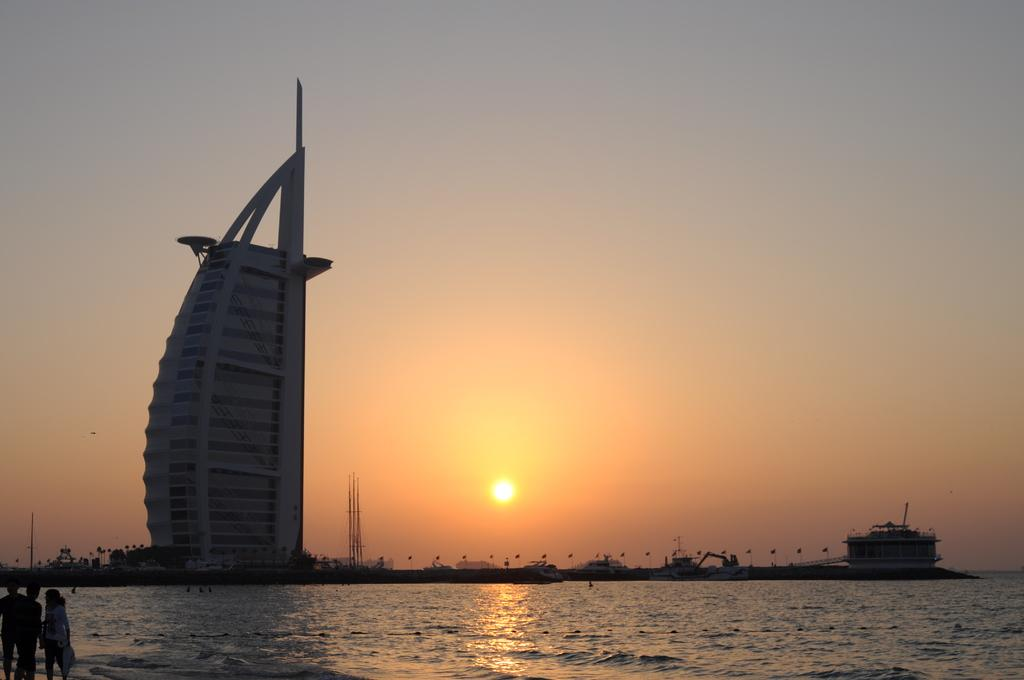How many people are present in the image? There are persons standing in the image. What is the primary element visible in the image? There is water visible in the image. What can be seen in the background of the image? There is a building in the background of the image, and the sky is clear. What type of distribution system is being used by the friends in the image? There is no mention of friends or any distribution system in the image. 